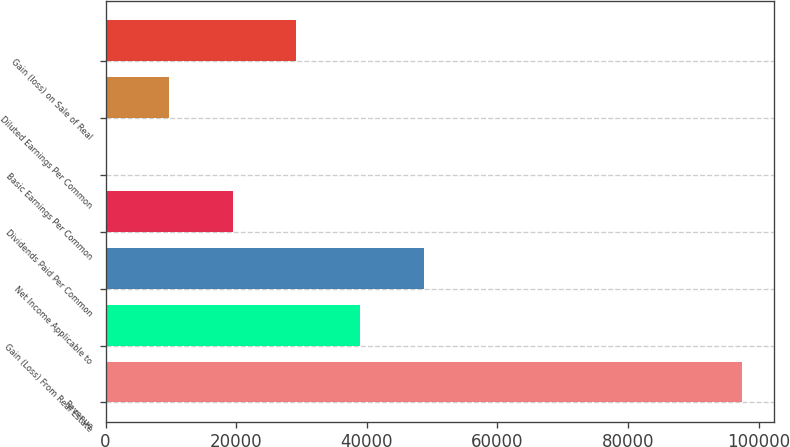Convert chart to OTSL. <chart><loc_0><loc_0><loc_500><loc_500><bar_chart><fcel>Revenue<fcel>Gain (Loss) From Real Estate<fcel>Net Income Applicable to<fcel>Dividends Paid Per Common<fcel>Basic Earnings Per Common<fcel>Diluted Earnings Per Common<fcel>Gain (loss) on Sale of Real<nl><fcel>97412<fcel>38964.9<fcel>48706.1<fcel>19482.5<fcel>0.17<fcel>9741.35<fcel>29223.7<nl></chart> 